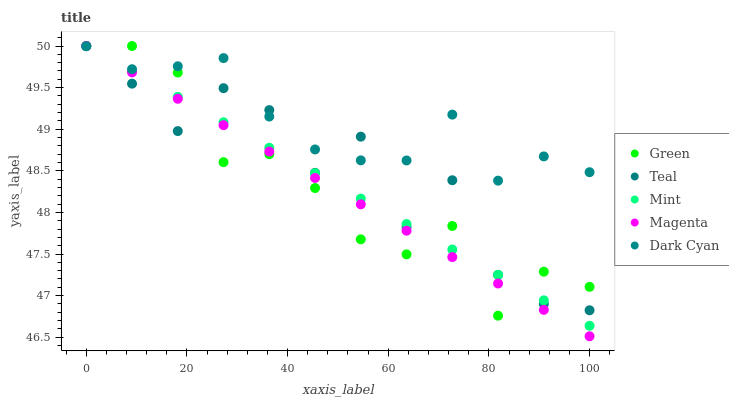Does Magenta have the minimum area under the curve?
Answer yes or no. Yes. Does Dark Cyan have the maximum area under the curve?
Answer yes or no. Yes. Does Mint have the minimum area under the curve?
Answer yes or no. No. Does Mint have the maximum area under the curve?
Answer yes or no. No. Is Magenta the smoothest?
Answer yes or no. Yes. Is Teal the roughest?
Answer yes or no. Yes. Is Mint the smoothest?
Answer yes or no. No. Is Mint the roughest?
Answer yes or no. No. Does Magenta have the lowest value?
Answer yes or no. Yes. Does Mint have the lowest value?
Answer yes or no. No. Does Teal have the highest value?
Answer yes or no. Yes. Does Mint intersect Dark Cyan?
Answer yes or no. Yes. Is Mint less than Dark Cyan?
Answer yes or no. No. Is Mint greater than Dark Cyan?
Answer yes or no. No. 